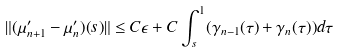Convert formula to latex. <formula><loc_0><loc_0><loc_500><loc_500>\| ( \mu _ { n + 1 } ^ { \prime } - \mu _ { n } ^ { \prime } ) ( s ) \| \leq C \epsilon + C \int _ { s } ^ { 1 } ( \gamma _ { n - 1 } ( \tau ) + \gamma _ { n } ( \tau ) ) d \tau</formula> 